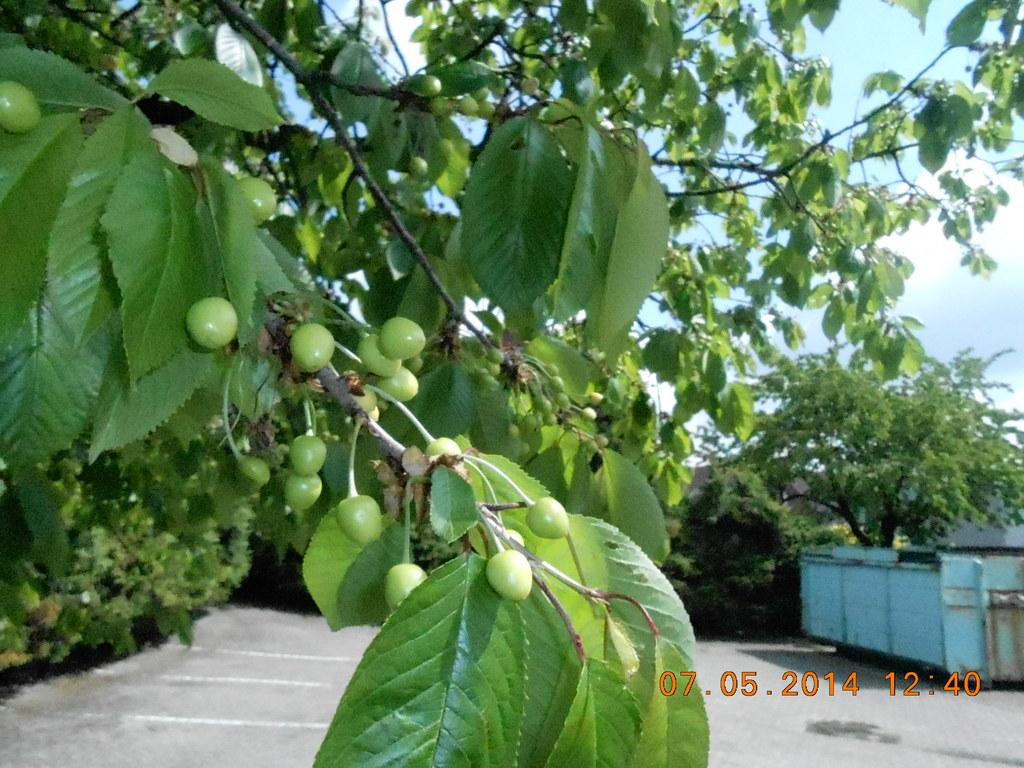What type of vegetation is present in the image? There are trees in the image. What else can be seen in the image besides trees? There are fruits in the image. What can be seen in the background of the image? There is a truck in the background of the image. What additional information is displayed at the bottom of the image? The image displays time and date at the bottom. What type of operation is being performed on the pail in the image? There is no pail present in the image, so no operation can be observed. 